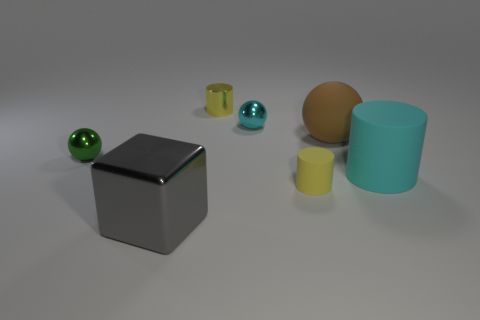Is the material of the tiny object to the left of the gray shiny block the same as the big cyan object? no 